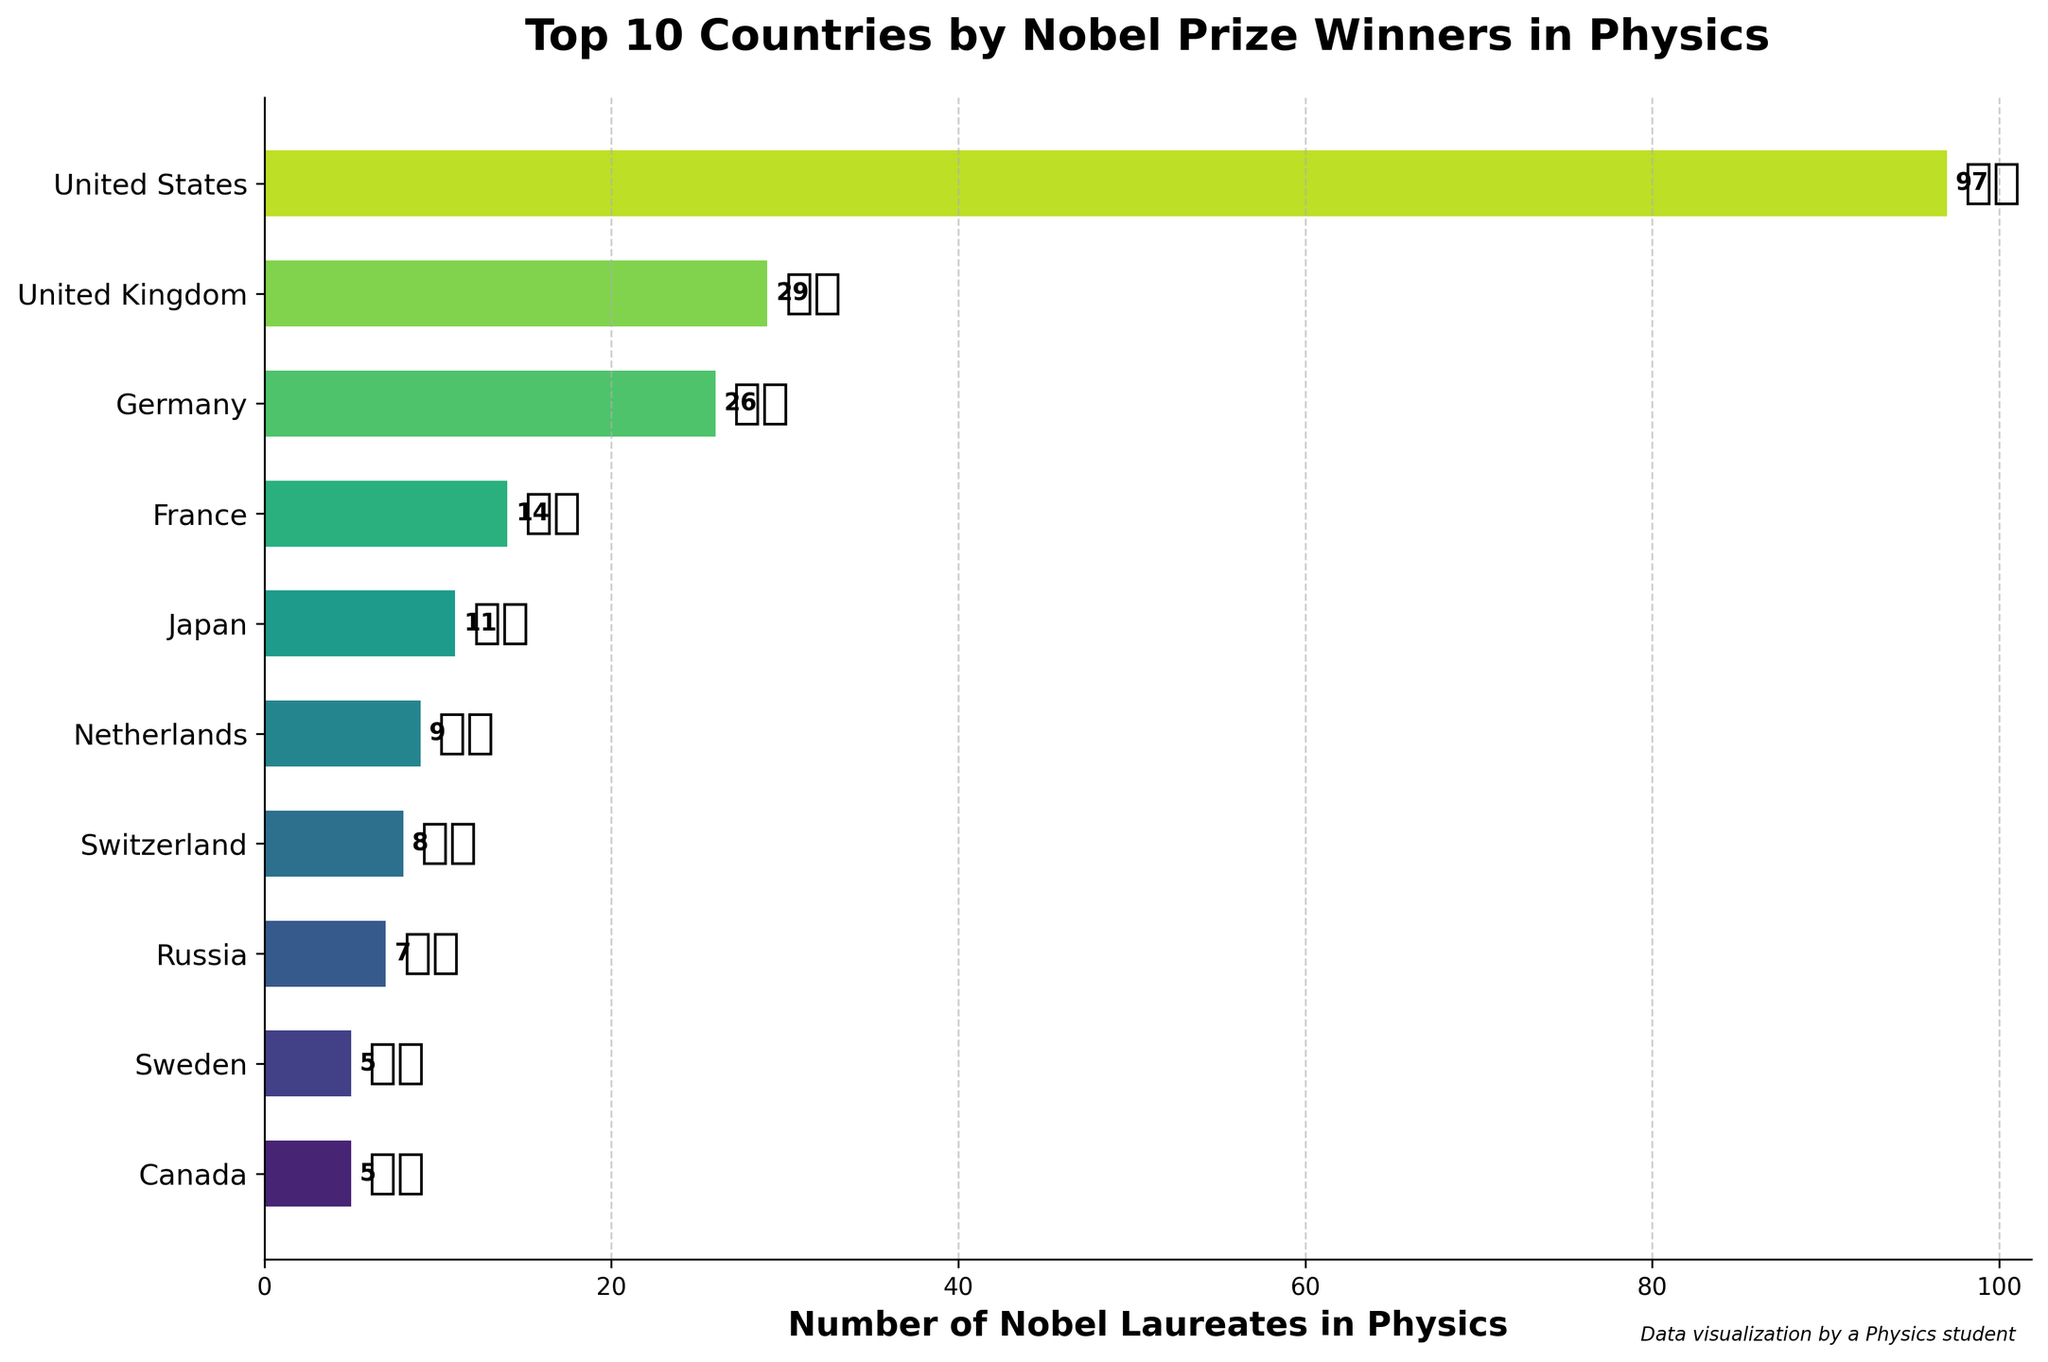What's the total number of Nobel Laureates in Physics for the top 3 countries? Add the laureates of the United States, United Kingdom, and Germany: 97 + 29 + 26 = 152
Answer: 152 How many more Nobel Laureates does the United States have compared to the United Kingdom? Subtract the number of UK laureates from the US laureates: 97 - 29 = 68
Answer: 68 Which country has the fourth highest number of Nobel Laureates in Physics? Refer to the fourth entry from the top, which is France with 14 laureates
Answer: France What's the difference in the number of Nobel Laureates between Japan and Germany? Subtract the number of Japan's laureates from Germany's laureates: 26 - 11 = 15
Answer: 15 Which country is depicted with the shortest bar in the top 10 list? Identify the shortest bar, which corresponds to Canada and Sweden, each with 5 laureates
Answer: Canada/Sweden What's the average number of Nobel Laureates among the top 5 countries? Sum the laureates of the top 5 countries (97 + 29 + 26 + 14 + 11 = 177) and divide by 5: 177 / 5 = 35.4
Answer: 35.4 How does the number of Nobel Laureates in Switzerland compare to that in the Netherlands? Switzerland has 1 fewer laureate than the Netherlands: 9 - 8 = 1
Answer: 1 fewer How many Nobel Laureates in Physics are represented in total by the top 10 countries? Sum all laureates in the top 10 countries: 97 + 29 + 26 + 14 + 11 + 9 + 8 + 7 + 5 + 5 = 211
Answer: 211 Which country's bar is colored the lightest green? The bar representing France is the lightest as it is the fifth one in the colormap sequence
Answer: France 